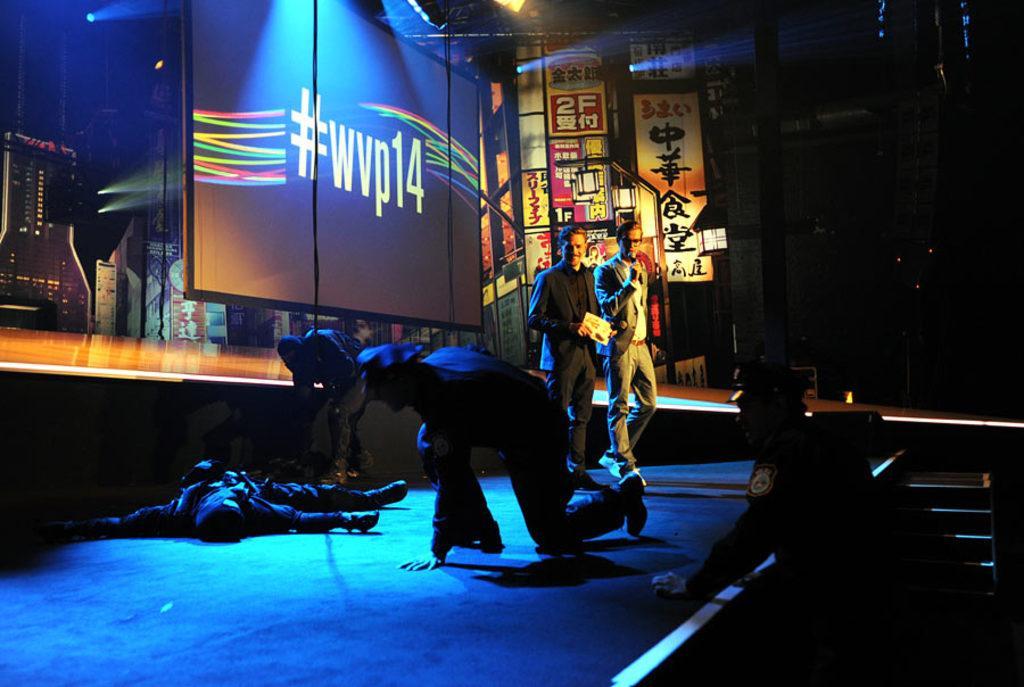How would you summarize this image in a sentence or two? In the picture I can see two men standing on the floor. I can see one of them speaking on a microphone and the other man is holding a paper and there is a smile on his face. I can see a person on the floor and looks like he is unconscious state. I can see a policeman on the right side. Here I can see staircases and there are posters and text on it. 